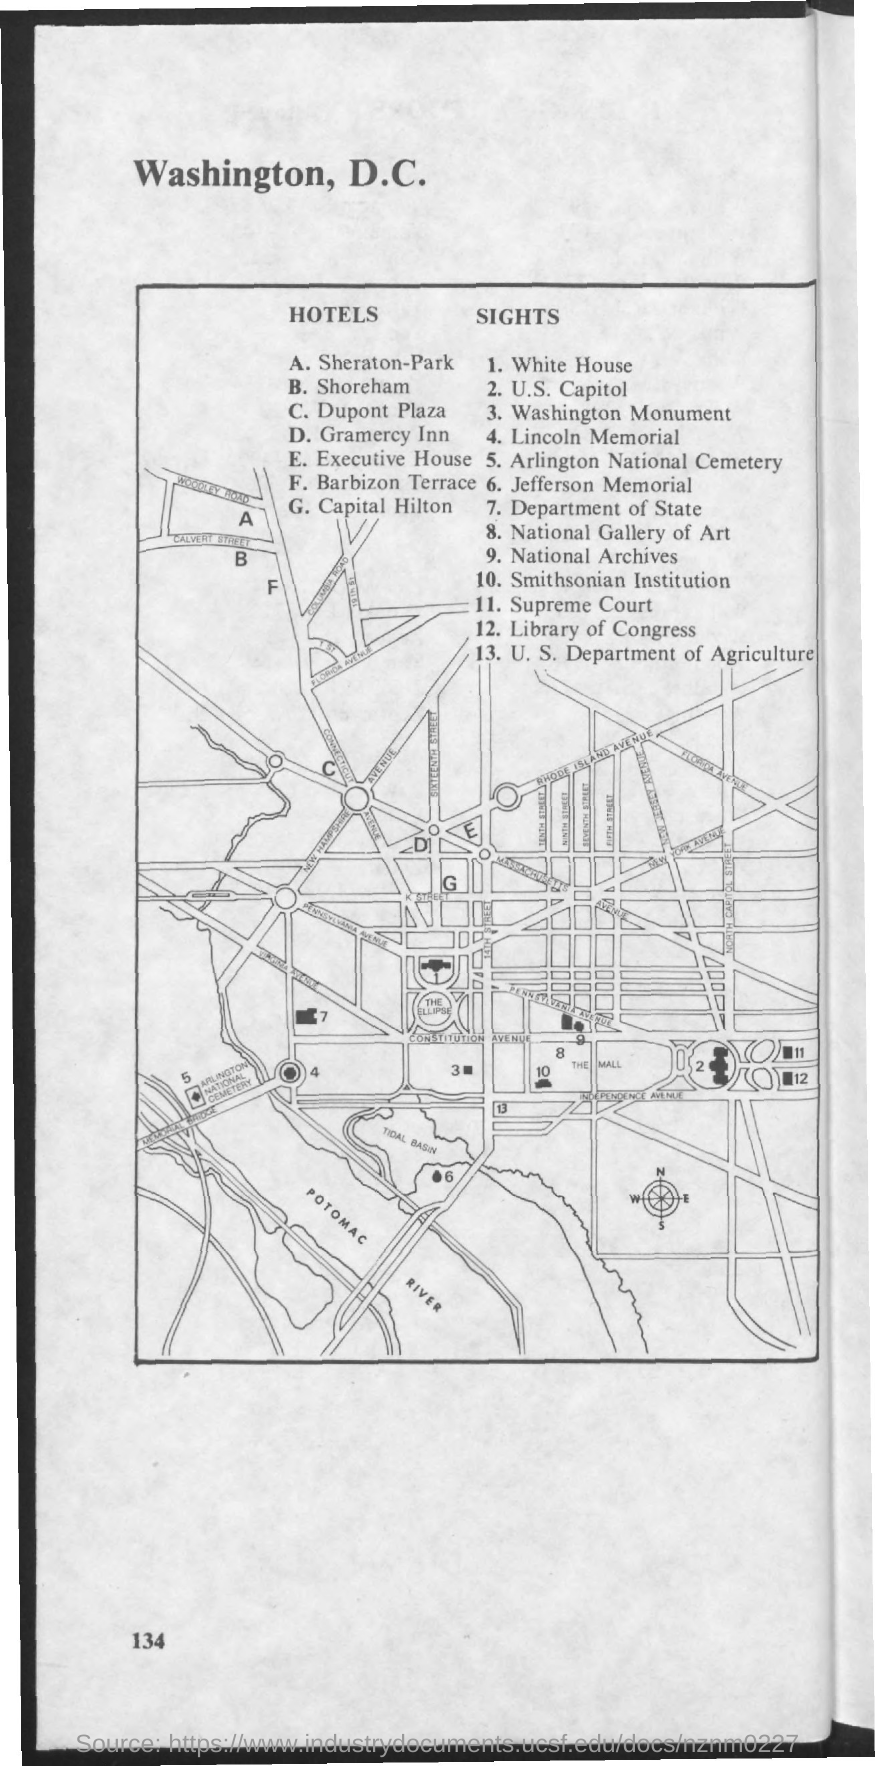List a handful of essential elements in this visual. The number 11 represents the sight of the Supreme Court. The first title in the document is 'Washington, D.C.', which provides an overview of the city's history, landmarks, and notable figures. The Capital Hilton hotel is represented by the letter "G". The number 1 represents the sight of the White House. 